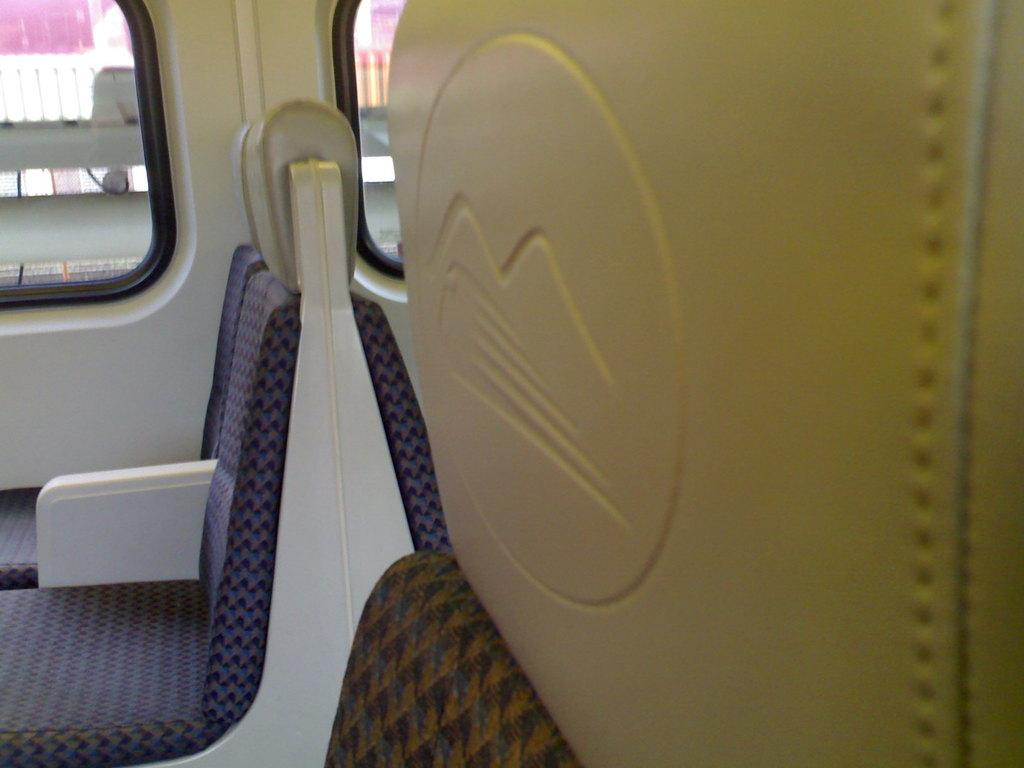What type of space is depicted in the image? The image shows an inside view of a vehicle. What can be seen in the foreground of the image? There are seats in the foreground of the image. What is visible in the background of the image? There are windows and a railing visible in the background of the image. What type of beast can be seen lurking in the shadows of the image? There is no beast present in the image; it depicts an inside view of a vehicle with seats, windows, and a railing. 